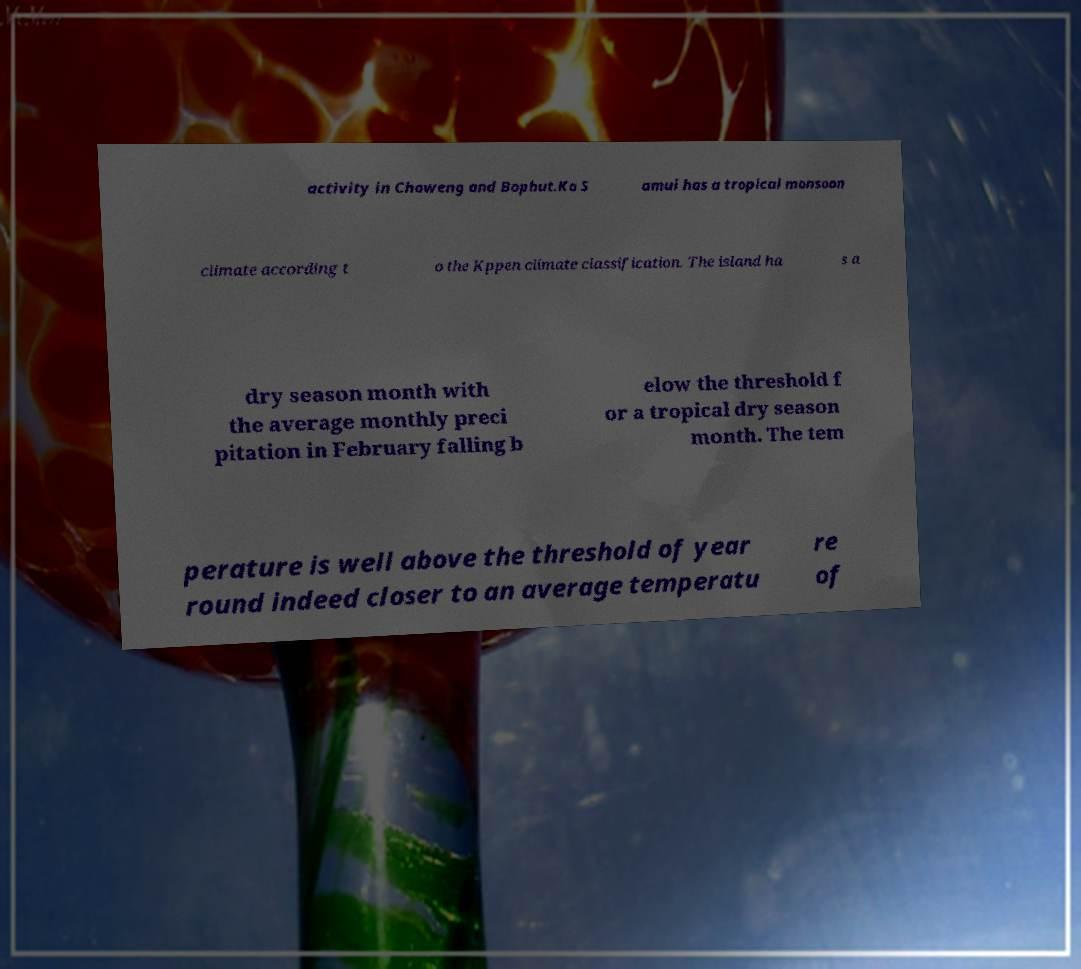Please read and relay the text visible in this image. What does it say? activity in Chaweng and Bophut.Ko S amui has a tropical monsoon climate according t o the Kppen climate classification. The island ha s a dry season month with the average monthly preci pitation in February falling b elow the threshold f or a tropical dry season month. The tem perature is well above the threshold of year round indeed closer to an average temperatu re of 